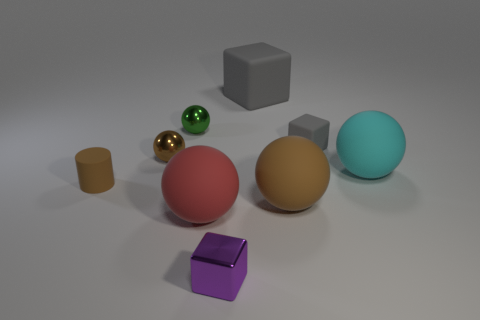Subtract all large cyan balls. How many balls are left? 4 Subtract all red balls. How many balls are left? 4 Subtract 1 balls. How many balls are left? 4 Subtract all yellow spheres. Subtract all cyan cubes. How many spheres are left? 5 Add 1 big cyan spheres. How many objects exist? 10 Subtract all balls. How many objects are left? 4 Add 3 large brown rubber balls. How many large brown rubber balls are left? 4 Add 5 brown shiny spheres. How many brown shiny spheres exist? 6 Subtract 0 brown blocks. How many objects are left? 9 Subtract all large cyan rubber spheres. Subtract all green spheres. How many objects are left? 7 